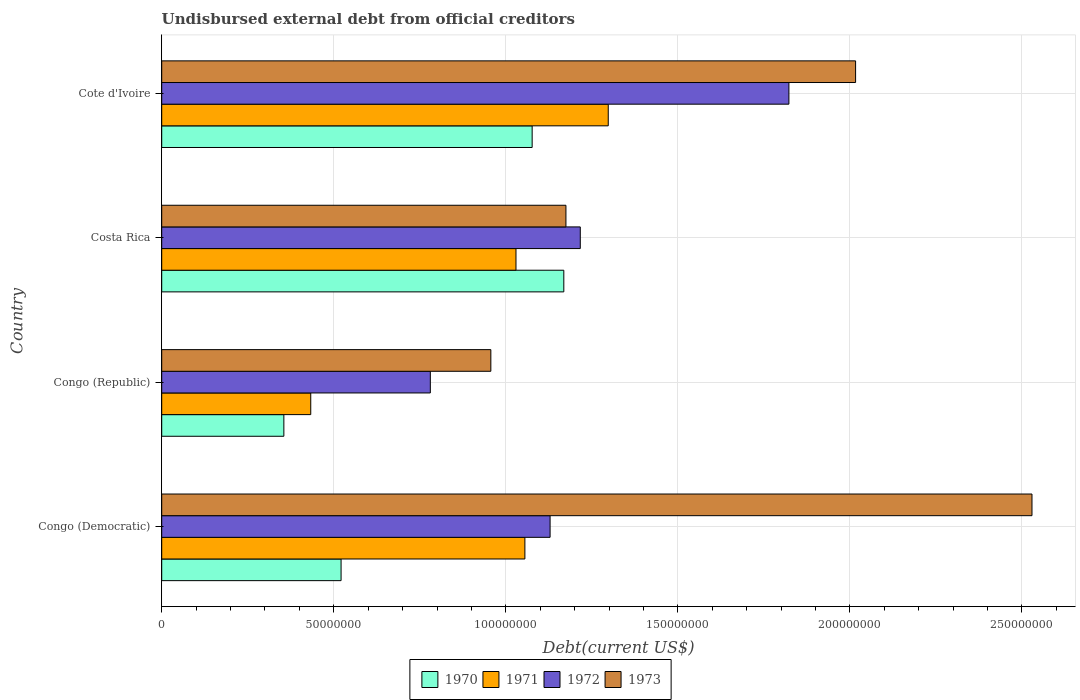How many groups of bars are there?
Offer a very short reply. 4. Are the number of bars on each tick of the Y-axis equal?
Give a very brief answer. Yes. How many bars are there on the 2nd tick from the top?
Provide a short and direct response. 4. What is the label of the 1st group of bars from the top?
Offer a very short reply. Cote d'Ivoire. What is the total debt in 1972 in Congo (Democratic)?
Offer a terse response. 1.13e+08. Across all countries, what is the maximum total debt in 1972?
Give a very brief answer. 1.82e+08. Across all countries, what is the minimum total debt in 1973?
Provide a short and direct response. 9.56e+07. In which country was the total debt in 1971 maximum?
Provide a short and direct response. Cote d'Ivoire. In which country was the total debt in 1970 minimum?
Your response must be concise. Congo (Republic). What is the total total debt in 1973 in the graph?
Your response must be concise. 6.68e+08. What is the difference between the total debt in 1972 in Congo (Republic) and that in Costa Rica?
Make the answer very short. -4.36e+07. What is the difference between the total debt in 1971 in Congo (Democratic) and the total debt in 1973 in Costa Rica?
Keep it short and to the point. -1.19e+07. What is the average total debt in 1973 per country?
Your response must be concise. 1.67e+08. What is the difference between the total debt in 1970 and total debt in 1973 in Congo (Democratic)?
Provide a succinct answer. -2.01e+08. What is the ratio of the total debt in 1970 in Congo (Democratic) to that in Congo (Republic)?
Provide a short and direct response. 1.47. Is the total debt in 1973 in Congo (Republic) less than that in Cote d'Ivoire?
Your answer should be very brief. Yes. Is the difference between the total debt in 1970 in Congo (Democratic) and Cote d'Ivoire greater than the difference between the total debt in 1973 in Congo (Democratic) and Cote d'Ivoire?
Your answer should be compact. No. What is the difference between the highest and the second highest total debt in 1972?
Offer a very short reply. 6.06e+07. What is the difference between the highest and the lowest total debt in 1971?
Provide a succinct answer. 8.65e+07. Is the sum of the total debt in 1972 in Congo (Democratic) and Congo (Republic) greater than the maximum total debt in 1970 across all countries?
Provide a short and direct response. Yes. Is it the case that in every country, the sum of the total debt in 1970 and total debt in 1972 is greater than the sum of total debt in 1973 and total debt in 1971?
Your answer should be very brief. No. Is it the case that in every country, the sum of the total debt in 1973 and total debt in 1972 is greater than the total debt in 1971?
Offer a very short reply. Yes. How many countries are there in the graph?
Provide a short and direct response. 4. Are the values on the major ticks of X-axis written in scientific E-notation?
Give a very brief answer. No. Does the graph contain any zero values?
Your answer should be very brief. No. Does the graph contain grids?
Provide a short and direct response. Yes. How are the legend labels stacked?
Your answer should be compact. Horizontal. What is the title of the graph?
Keep it short and to the point. Undisbursed external debt from official creditors. What is the label or title of the X-axis?
Offer a terse response. Debt(current US$). What is the label or title of the Y-axis?
Offer a terse response. Country. What is the Debt(current US$) of 1970 in Congo (Democratic)?
Your answer should be compact. 5.21e+07. What is the Debt(current US$) of 1971 in Congo (Democratic)?
Provide a short and direct response. 1.06e+08. What is the Debt(current US$) in 1972 in Congo (Democratic)?
Offer a terse response. 1.13e+08. What is the Debt(current US$) in 1973 in Congo (Democratic)?
Offer a very short reply. 2.53e+08. What is the Debt(current US$) of 1970 in Congo (Republic)?
Provide a succinct answer. 3.55e+07. What is the Debt(current US$) in 1971 in Congo (Republic)?
Make the answer very short. 4.33e+07. What is the Debt(current US$) in 1972 in Congo (Republic)?
Give a very brief answer. 7.81e+07. What is the Debt(current US$) in 1973 in Congo (Republic)?
Your response must be concise. 9.56e+07. What is the Debt(current US$) in 1970 in Costa Rica?
Ensure brevity in your answer.  1.17e+08. What is the Debt(current US$) in 1971 in Costa Rica?
Make the answer very short. 1.03e+08. What is the Debt(current US$) of 1972 in Costa Rica?
Offer a very short reply. 1.22e+08. What is the Debt(current US$) in 1973 in Costa Rica?
Provide a succinct answer. 1.17e+08. What is the Debt(current US$) in 1970 in Cote d'Ivoire?
Give a very brief answer. 1.08e+08. What is the Debt(current US$) of 1971 in Cote d'Ivoire?
Provide a short and direct response. 1.30e+08. What is the Debt(current US$) of 1972 in Cote d'Ivoire?
Keep it short and to the point. 1.82e+08. What is the Debt(current US$) of 1973 in Cote d'Ivoire?
Your answer should be very brief. 2.02e+08. Across all countries, what is the maximum Debt(current US$) in 1970?
Your answer should be very brief. 1.17e+08. Across all countries, what is the maximum Debt(current US$) of 1971?
Provide a succinct answer. 1.30e+08. Across all countries, what is the maximum Debt(current US$) in 1972?
Offer a terse response. 1.82e+08. Across all countries, what is the maximum Debt(current US$) in 1973?
Give a very brief answer. 2.53e+08. Across all countries, what is the minimum Debt(current US$) in 1970?
Your response must be concise. 3.55e+07. Across all countries, what is the minimum Debt(current US$) in 1971?
Make the answer very short. 4.33e+07. Across all countries, what is the minimum Debt(current US$) in 1972?
Keep it short and to the point. 7.81e+07. Across all countries, what is the minimum Debt(current US$) of 1973?
Your response must be concise. 9.56e+07. What is the total Debt(current US$) of 1970 in the graph?
Your response must be concise. 3.12e+08. What is the total Debt(current US$) of 1971 in the graph?
Keep it short and to the point. 3.82e+08. What is the total Debt(current US$) of 1972 in the graph?
Give a very brief answer. 4.95e+08. What is the total Debt(current US$) of 1973 in the graph?
Provide a short and direct response. 6.68e+08. What is the difference between the Debt(current US$) in 1970 in Congo (Democratic) and that in Congo (Republic)?
Ensure brevity in your answer.  1.66e+07. What is the difference between the Debt(current US$) of 1971 in Congo (Democratic) and that in Congo (Republic)?
Offer a very short reply. 6.22e+07. What is the difference between the Debt(current US$) in 1972 in Congo (Democratic) and that in Congo (Republic)?
Your answer should be compact. 3.48e+07. What is the difference between the Debt(current US$) in 1973 in Congo (Democratic) and that in Congo (Republic)?
Ensure brevity in your answer.  1.57e+08. What is the difference between the Debt(current US$) in 1970 in Congo (Democratic) and that in Costa Rica?
Offer a very short reply. -6.47e+07. What is the difference between the Debt(current US$) of 1971 in Congo (Democratic) and that in Costa Rica?
Make the answer very short. 2.59e+06. What is the difference between the Debt(current US$) of 1972 in Congo (Democratic) and that in Costa Rica?
Provide a succinct answer. -8.77e+06. What is the difference between the Debt(current US$) in 1973 in Congo (Democratic) and that in Costa Rica?
Keep it short and to the point. 1.35e+08. What is the difference between the Debt(current US$) in 1970 in Congo (Democratic) and that in Cote d'Ivoire?
Your answer should be very brief. -5.55e+07. What is the difference between the Debt(current US$) of 1971 in Congo (Democratic) and that in Cote d'Ivoire?
Offer a terse response. -2.42e+07. What is the difference between the Debt(current US$) in 1972 in Congo (Democratic) and that in Cote d'Ivoire?
Provide a short and direct response. -6.94e+07. What is the difference between the Debt(current US$) of 1973 in Congo (Democratic) and that in Cote d'Ivoire?
Your answer should be compact. 5.13e+07. What is the difference between the Debt(current US$) in 1970 in Congo (Republic) and that in Costa Rica?
Your response must be concise. -8.14e+07. What is the difference between the Debt(current US$) of 1971 in Congo (Republic) and that in Costa Rica?
Your answer should be very brief. -5.96e+07. What is the difference between the Debt(current US$) in 1972 in Congo (Republic) and that in Costa Rica?
Offer a terse response. -4.36e+07. What is the difference between the Debt(current US$) in 1973 in Congo (Republic) and that in Costa Rica?
Your answer should be compact. -2.18e+07. What is the difference between the Debt(current US$) of 1970 in Congo (Republic) and that in Cote d'Ivoire?
Ensure brevity in your answer.  -7.22e+07. What is the difference between the Debt(current US$) of 1971 in Congo (Republic) and that in Cote d'Ivoire?
Offer a terse response. -8.65e+07. What is the difference between the Debt(current US$) in 1972 in Congo (Republic) and that in Cote d'Ivoire?
Your answer should be compact. -1.04e+08. What is the difference between the Debt(current US$) in 1973 in Congo (Republic) and that in Cote d'Ivoire?
Keep it short and to the point. -1.06e+08. What is the difference between the Debt(current US$) in 1970 in Costa Rica and that in Cote d'Ivoire?
Provide a short and direct response. 9.20e+06. What is the difference between the Debt(current US$) in 1971 in Costa Rica and that in Cote d'Ivoire?
Your answer should be compact. -2.68e+07. What is the difference between the Debt(current US$) of 1972 in Costa Rica and that in Cote d'Ivoire?
Provide a succinct answer. -6.06e+07. What is the difference between the Debt(current US$) in 1973 in Costa Rica and that in Cote d'Ivoire?
Ensure brevity in your answer.  -8.42e+07. What is the difference between the Debt(current US$) in 1970 in Congo (Democratic) and the Debt(current US$) in 1971 in Congo (Republic)?
Provide a short and direct response. 8.81e+06. What is the difference between the Debt(current US$) in 1970 in Congo (Democratic) and the Debt(current US$) in 1972 in Congo (Republic)?
Provide a short and direct response. -2.59e+07. What is the difference between the Debt(current US$) in 1970 in Congo (Democratic) and the Debt(current US$) in 1973 in Congo (Republic)?
Provide a succinct answer. -4.35e+07. What is the difference between the Debt(current US$) of 1971 in Congo (Democratic) and the Debt(current US$) of 1972 in Congo (Republic)?
Your answer should be very brief. 2.75e+07. What is the difference between the Debt(current US$) of 1971 in Congo (Democratic) and the Debt(current US$) of 1973 in Congo (Republic)?
Your answer should be compact. 9.89e+06. What is the difference between the Debt(current US$) in 1972 in Congo (Democratic) and the Debt(current US$) in 1973 in Congo (Republic)?
Your response must be concise. 1.72e+07. What is the difference between the Debt(current US$) in 1970 in Congo (Democratic) and the Debt(current US$) in 1971 in Costa Rica?
Keep it short and to the point. -5.08e+07. What is the difference between the Debt(current US$) of 1970 in Congo (Democratic) and the Debt(current US$) of 1972 in Costa Rica?
Offer a very short reply. -6.95e+07. What is the difference between the Debt(current US$) in 1970 in Congo (Democratic) and the Debt(current US$) in 1973 in Costa Rica?
Your response must be concise. -6.53e+07. What is the difference between the Debt(current US$) in 1971 in Congo (Democratic) and the Debt(current US$) in 1972 in Costa Rica?
Keep it short and to the point. -1.61e+07. What is the difference between the Debt(current US$) of 1971 in Congo (Democratic) and the Debt(current US$) of 1973 in Costa Rica?
Your answer should be very brief. -1.19e+07. What is the difference between the Debt(current US$) in 1972 in Congo (Democratic) and the Debt(current US$) in 1973 in Costa Rica?
Provide a short and direct response. -4.61e+06. What is the difference between the Debt(current US$) of 1970 in Congo (Democratic) and the Debt(current US$) of 1971 in Cote d'Ivoire?
Provide a short and direct response. -7.76e+07. What is the difference between the Debt(current US$) of 1970 in Congo (Democratic) and the Debt(current US$) of 1972 in Cote d'Ivoire?
Ensure brevity in your answer.  -1.30e+08. What is the difference between the Debt(current US$) of 1970 in Congo (Democratic) and the Debt(current US$) of 1973 in Cote d'Ivoire?
Offer a terse response. -1.50e+08. What is the difference between the Debt(current US$) in 1971 in Congo (Democratic) and the Debt(current US$) in 1972 in Cote d'Ivoire?
Provide a succinct answer. -7.67e+07. What is the difference between the Debt(current US$) in 1971 in Congo (Democratic) and the Debt(current US$) in 1973 in Cote d'Ivoire?
Provide a succinct answer. -9.61e+07. What is the difference between the Debt(current US$) of 1972 in Congo (Democratic) and the Debt(current US$) of 1973 in Cote d'Ivoire?
Your response must be concise. -8.88e+07. What is the difference between the Debt(current US$) in 1970 in Congo (Republic) and the Debt(current US$) in 1971 in Costa Rica?
Make the answer very short. -6.75e+07. What is the difference between the Debt(current US$) of 1970 in Congo (Republic) and the Debt(current US$) of 1972 in Costa Rica?
Make the answer very short. -8.61e+07. What is the difference between the Debt(current US$) in 1970 in Congo (Republic) and the Debt(current US$) in 1973 in Costa Rica?
Provide a short and direct response. -8.20e+07. What is the difference between the Debt(current US$) of 1971 in Congo (Republic) and the Debt(current US$) of 1972 in Costa Rica?
Offer a terse response. -7.83e+07. What is the difference between the Debt(current US$) of 1971 in Congo (Republic) and the Debt(current US$) of 1973 in Costa Rica?
Provide a short and direct response. -7.42e+07. What is the difference between the Debt(current US$) of 1972 in Congo (Republic) and the Debt(current US$) of 1973 in Costa Rica?
Make the answer very short. -3.94e+07. What is the difference between the Debt(current US$) in 1970 in Congo (Republic) and the Debt(current US$) in 1971 in Cote d'Ivoire?
Make the answer very short. -9.43e+07. What is the difference between the Debt(current US$) in 1970 in Congo (Republic) and the Debt(current US$) in 1972 in Cote d'Ivoire?
Your answer should be very brief. -1.47e+08. What is the difference between the Debt(current US$) of 1970 in Congo (Republic) and the Debt(current US$) of 1973 in Cote d'Ivoire?
Ensure brevity in your answer.  -1.66e+08. What is the difference between the Debt(current US$) in 1971 in Congo (Republic) and the Debt(current US$) in 1972 in Cote d'Ivoire?
Provide a succinct answer. -1.39e+08. What is the difference between the Debt(current US$) of 1971 in Congo (Republic) and the Debt(current US$) of 1973 in Cote d'Ivoire?
Offer a terse response. -1.58e+08. What is the difference between the Debt(current US$) of 1972 in Congo (Republic) and the Debt(current US$) of 1973 in Cote d'Ivoire?
Ensure brevity in your answer.  -1.24e+08. What is the difference between the Debt(current US$) in 1970 in Costa Rica and the Debt(current US$) in 1971 in Cote d'Ivoire?
Your response must be concise. -1.29e+07. What is the difference between the Debt(current US$) in 1970 in Costa Rica and the Debt(current US$) in 1972 in Cote d'Ivoire?
Make the answer very short. -6.54e+07. What is the difference between the Debt(current US$) in 1970 in Costa Rica and the Debt(current US$) in 1973 in Cote d'Ivoire?
Give a very brief answer. -8.48e+07. What is the difference between the Debt(current US$) of 1971 in Costa Rica and the Debt(current US$) of 1972 in Cote d'Ivoire?
Provide a succinct answer. -7.93e+07. What is the difference between the Debt(current US$) in 1971 in Costa Rica and the Debt(current US$) in 1973 in Cote d'Ivoire?
Ensure brevity in your answer.  -9.87e+07. What is the difference between the Debt(current US$) in 1972 in Costa Rica and the Debt(current US$) in 1973 in Cote d'Ivoire?
Provide a short and direct response. -8.00e+07. What is the average Debt(current US$) of 1970 per country?
Make the answer very short. 7.80e+07. What is the average Debt(current US$) of 1971 per country?
Make the answer very short. 9.54e+07. What is the average Debt(current US$) of 1972 per country?
Provide a short and direct response. 1.24e+08. What is the average Debt(current US$) of 1973 per country?
Provide a short and direct response. 1.67e+08. What is the difference between the Debt(current US$) in 1970 and Debt(current US$) in 1971 in Congo (Democratic)?
Offer a very short reply. -5.34e+07. What is the difference between the Debt(current US$) of 1970 and Debt(current US$) of 1972 in Congo (Democratic)?
Provide a short and direct response. -6.07e+07. What is the difference between the Debt(current US$) of 1970 and Debt(current US$) of 1973 in Congo (Democratic)?
Make the answer very short. -2.01e+08. What is the difference between the Debt(current US$) of 1971 and Debt(current US$) of 1972 in Congo (Democratic)?
Provide a succinct answer. -7.32e+06. What is the difference between the Debt(current US$) of 1971 and Debt(current US$) of 1973 in Congo (Democratic)?
Provide a short and direct response. -1.47e+08. What is the difference between the Debt(current US$) of 1972 and Debt(current US$) of 1973 in Congo (Democratic)?
Ensure brevity in your answer.  -1.40e+08. What is the difference between the Debt(current US$) of 1970 and Debt(current US$) of 1971 in Congo (Republic)?
Ensure brevity in your answer.  -7.82e+06. What is the difference between the Debt(current US$) in 1970 and Debt(current US$) in 1972 in Congo (Republic)?
Your response must be concise. -4.26e+07. What is the difference between the Debt(current US$) of 1970 and Debt(current US$) of 1973 in Congo (Republic)?
Your answer should be very brief. -6.02e+07. What is the difference between the Debt(current US$) in 1971 and Debt(current US$) in 1972 in Congo (Republic)?
Provide a short and direct response. -3.47e+07. What is the difference between the Debt(current US$) in 1971 and Debt(current US$) in 1973 in Congo (Republic)?
Your answer should be very brief. -5.23e+07. What is the difference between the Debt(current US$) of 1972 and Debt(current US$) of 1973 in Congo (Republic)?
Provide a short and direct response. -1.76e+07. What is the difference between the Debt(current US$) in 1970 and Debt(current US$) in 1971 in Costa Rica?
Provide a short and direct response. 1.39e+07. What is the difference between the Debt(current US$) in 1970 and Debt(current US$) in 1972 in Costa Rica?
Keep it short and to the point. -4.78e+06. What is the difference between the Debt(current US$) of 1970 and Debt(current US$) of 1973 in Costa Rica?
Provide a succinct answer. -6.18e+05. What is the difference between the Debt(current US$) of 1971 and Debt(current US$) of 1972 in Costa Rica?
Your answer should be compact. -1.87e+07. What is the difference between the Debt(current US$) in 1971 and Debt(current US$) in 1973 in Costa Rica?
Keep it short and to the point. -1.45e+07. What is the difference between the Debt(current US$) in 1972 and Debt(current US$) in 1973 in Costa Rica?
Your response must be concise. 4.17e+06. What is the difference between the Debt(current US$) in 1970 and Debt(current US$) in 1971 in Cote d'Ivoire?
Ensure brevity in your answer.  -2.21e+07. What is the difference between the Debt(current US$) of 1970 and Debt(current US$) of 1972 in Cote d'Ivoire?
Provide a short and direct response. -7.46e+07. What is the difference between the Debt(current US$) in 1970 and Debt(current US$) in 1973 in Cote d'Ivoire?
Ensure brevity in your answer.  -9.40e+07. What is the difference between the Debt(current US$) in 1971 and Debt(current US$) in 1972 in Cote d'Ivoire?
Make the answer very short. -5.25e+07. What is the difference between the Debt(current US$) of 1971 and Debt(current US$) of 1973 in Cote d'Ivoire?
Keep it short and to the point. -7.19e+07. What is the difference between the Debt(current US$) in 1972 and Debt(current US$) in 1973 in Cote d'Ivoire?
Offer a very short reply. -1.94e+07. What is the ratio of the Debt(current US$) in 1970 in Congo (Democratic) to that in Congo (Republic)?
Offer a very short reply. 1.47. What is the ratio of the Debt(current US$) of 1971 in Congo (Democratic) to that in Congo (Republic)?
Your response must be concise. 2.44. What is the ratio of the Debt(current US$) in 1972 in Congo (Democratic) to that in Congo (Republic)?
Ensure brevity in your answer.  1.45. What is the ratio of the Debt(current US$) in 1973 in Congo (Democratic) to that in Congo (Republic)?
Offer a terse response. 2.64. What is the ratio of the Debt(current US$) of 1970 in Congo (Democratic) to that in Costa Rica?
Ensure brevity in your answer.  0.45. What is the ratio of the Debt(current US$) in 1971 in Congo (Democratic) to that in Costa Rica?
Offer a very short reply. 1.03. What is the ratio of the Debt(current US$) of 1972 in Congo (Democratic) to that in Costa Rica?
Your response must be concise. 0.93. What is the ratio of the Debt(current US$) of 1973 in Congo (Democratic) to that in Costa Rica?
Your answer should be compact. 2.15. What is the ratio of the Debt(current US$) in 1970 in Congo (Democratic) to that in Cote d'Ivoire?
Give a very brief answer. 0.48. What is the ratio of the Debt(current US$) in 1971 in Congo (Democratic) to that in Cote d'Ivoire?
Offer a terse response. 0.81. What is the ratio of the Debt(current US$) in 1972 in Congo (Democratic) to that in Cote d'Ivoire?
Offer a very short reply. 0.62. What is the ratio of the Debt(current US$) in 1973 in Congo (Democratic) to that in Cote d'Ivoire?
Your answer should be very brief. 1.25. What is the ratio of the Debt(current US$) of 1970 in Congo (Republic) to that in Costa Rica?
Keep it short and to the point. 0.3. What is the ratio of the Debt(current US$) of 1971 in Congo (Republic) to that in Costa Rica?
Provide a short and direct response. 0.42. What is the ratio of the Debt(current US$) in 1972 in Congo (Republic) to that in Costa Rica?
Provide a succinct answer. 0.64. What is the ratio of the Debt(current US$) in 1973 in Congo (Republic) to that in Costa Rica?
Your answer should be compact. 0.81. What is the ratio of the Debt(current US$) of 1970 in Congo (Republic) to that in Cote d'Ivoire?
Your answer should be compact. 0.33. What is the ratio of the Debt(current US$) of 1971 in Congo (Republic) to that in Cote d'Ivoire?
Offer a terse response. 0.33. What is the ratio of the Debt(current US$) in 1972 in Congo (Republic) to that in Cote d'Ivoire?
Your answer should be very brief. 0.43. What is the ratio of the Debt(current US$) in 1973 in Congo (Republic) to that in Cote d'Ivoire?
Make the answer very short. 0.47. What is the ratio of the Debt(current US$) in 1970 in Costa Rica to that in Cote d'Ivoire?
Your answer should be compact. 1.09. What is the ratio of the Debt(current US$) in 1971 in Costa Rica to that in Cote d'Ivoire?
Provide a short and direct response. 0.79. What is the ratio of the Debt(current US$) in 1972 in Costa Rica to that in Cote d'Ivoire?
Provide a succinct answer. 0.67. What is the ratio of the Debt(current US$) in 1973 in Costa Rica to that in Cote d'Ivoire?
Ensure brevity in your answer.  0.58. What is the difference between the highest and the second highest Debt(current US$) in 1970?
Keep it short and to the point. 9.20e+06. What is the difference between the highest and the second highest Debt(current US$) in 1971?
Keep it short and to the point. 2.42e+07. What is the difference between the highest and the second highest Debt(current US$) in 1972?
Give a very brief answer. 6.06e+07. What is the difference between the highest and the second highest Debt(current US$) in 1973?
Make the answer very short. 5.13e+07. What is the difference between the highest and the lowest Debt(current US$) of 1970?
Make the answer very short. 8.14e+07. What is the difference between the highest and the lowest Debt(current US$) of 1971?
Offer a terse response. 8.65e+07. What is the difference between the highest and the lowest Debt(current US$) of 1972?
Provide a short and direct response. 1.04e+08. What is the difference between the highest and the lowest Debt(current US$) of 1973?
Offer a very short reply. 1.57e+08. 